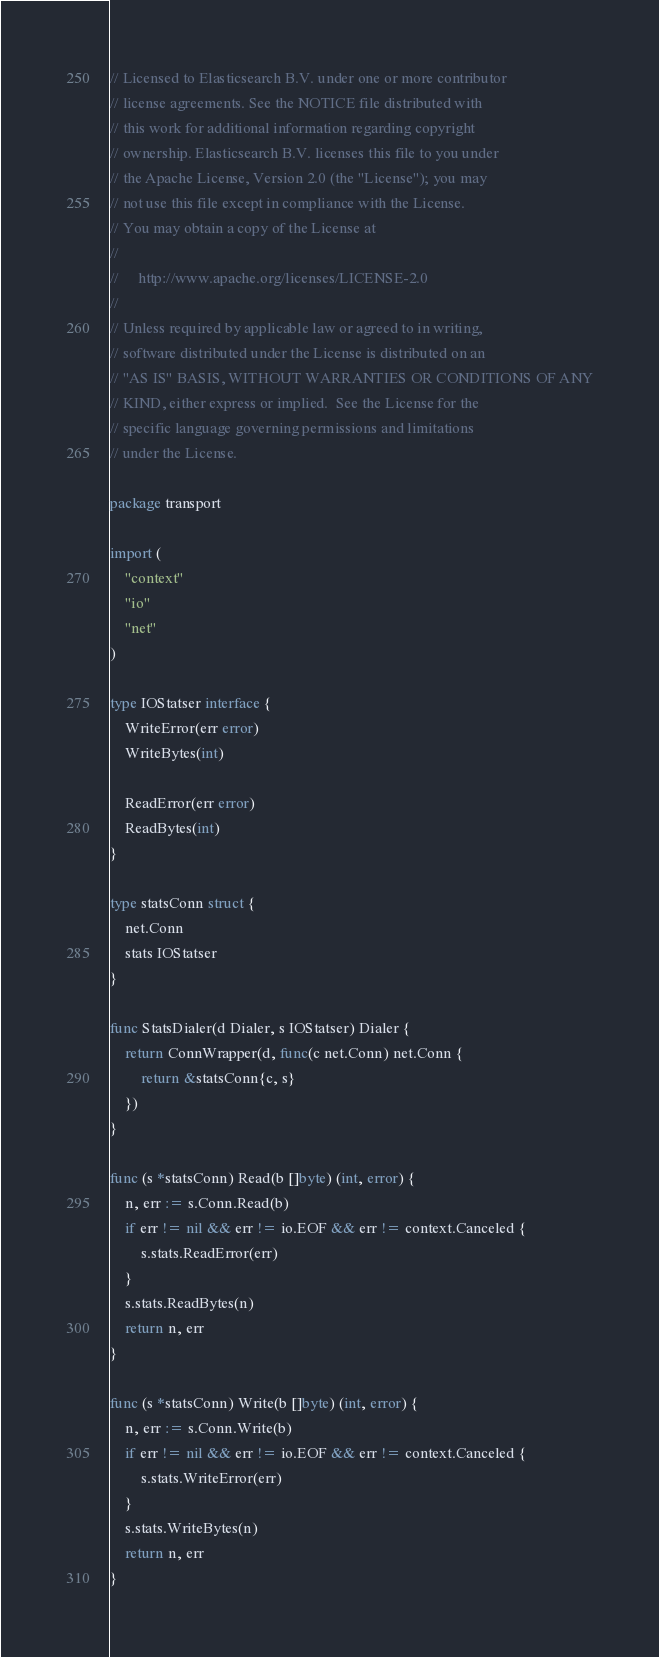Convert code to text. <code><loc_0><loc_0><loc_500><loc_500><_Go_>// Licensed to Elasticsearch B.V. under one or more contributor
// license agreements. See the NOTICE file distributed with
// this work for additional information regarding copyright
// ownership. Elasticsearch B.V. licenses this file to you under
// the Apache License, Version 2.0 (the "License"); you may
// not use this file except in compliance with the License.
// You may obtain a copy of the License at
//
//     http://www.apache.org/licenses/LICENSE-2.0
//
// Unless required by applicable law or agreed to in writing,
// software distributed under the License is distributed on an
// "AS IS" BASIS, WITHOUT WARRANTIES OR CONDITIONS OF ANY
// KIND, either express or implied.  See the License for the
// specific language governing permissions and limitations
// under the License.

package transport

import (
	"context"
	"io"
	"net"
)

type IOStatser interface {
	WriteError(err error)
	WriteBytes(int)

	ReadError(err error)
	ReadBytes(int)
}

type statsConn struct {
	net.Conn
	stats IOStatser
}

func StatsDialer(d Dialer, s IOStatser) Dialer {
	return ConnWrapper(d, func(c net.Conn) net.Conn {
		return &statsConn{c, s}
	})
}

func (s *statsConn) Read(b []byte) (int, error) {
	n, err := s.Conn.Read(b)
	if err != nil && err != io.EOF && err != context.Canceled {
		s.stats.ReadError(err)
	}
	s.stats.ReadBytes(n)
	return n, err
}

func (s *statsConn) Write(b []byte) (int, error) {
	n, err := s.Conn.Write(b)
	if err != nil && err != io.EOF && err != context.Canceled {
		s.stats.WriteError(err)
	}
	s.stats.WriteBytes(n)
	return n, err
}
</code> 